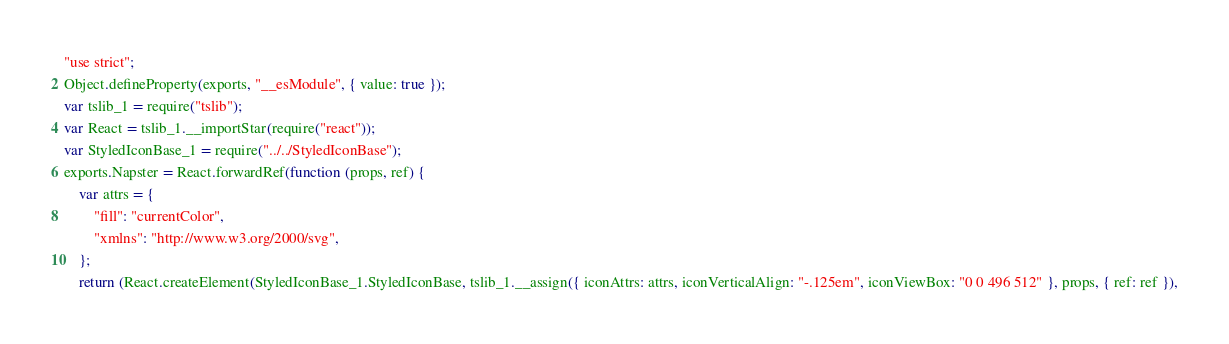Convert code to text. <code><loc_0><loc_0><loc_500><loc_500><_JavaScript_>"use strict";
Object.defineProperty(exports, "__esModule", { value: true });
var tslib_1 = require("tslib");
var React = tslib_1.__importStar(require("react"));
var StyledIconBase_1 = require("../../StyledIconBase");
exports.Napster = React.forwardRef(function (props, ref) {
    var attrs = {
        "fill": "currentColor",
        "xmlns": "http://www.w3.org/2000/svg",
    };
    return (React.createElement(StyledIconBase_1.StyledIconBase, tslib_1.__assign({ iconAttrs: attrs, iconVerticalAlign: "-.125em", iconViewBox: "0 0 496 512" }, props, { ref: ref }),</code> 